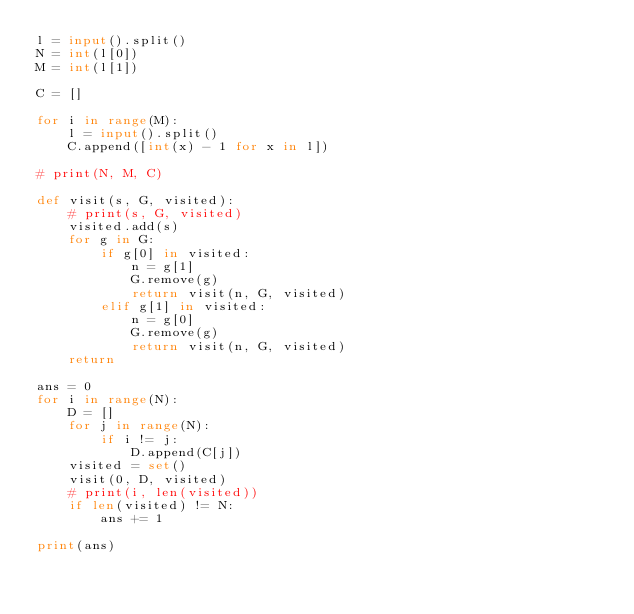<code> <loc_0><loc_0><loc_500><loc_500><_Python_>l = input().split()
N = int(l[0])
M = int(l[1])

C = []

for i in range(M):
    l = input().split()
    C.append([int(x) - 1 for x in l])

# print(N, M, C)

def visit(s, G, visited):
    # print(s, G, visited)
    visited.add(s)
    for g in G:
        if g[0] in visited:
            n = g[1]
            G.remove(g)
            return visit(n, G, visited)
        elif g[1] in visited:
            n = g[0]
            G.remove(g)
            return visit(n, G, visited)
    return

ans = 0
for i in range(N):
    D = []
    for j in range(N):
        if i != j:
            D.append(C[j])
    visited = set()
    visit(0, D, visited)
    # print(i, len(visited))
    if len(visited) != N:
        ans += 1

print(ans)
</code> 